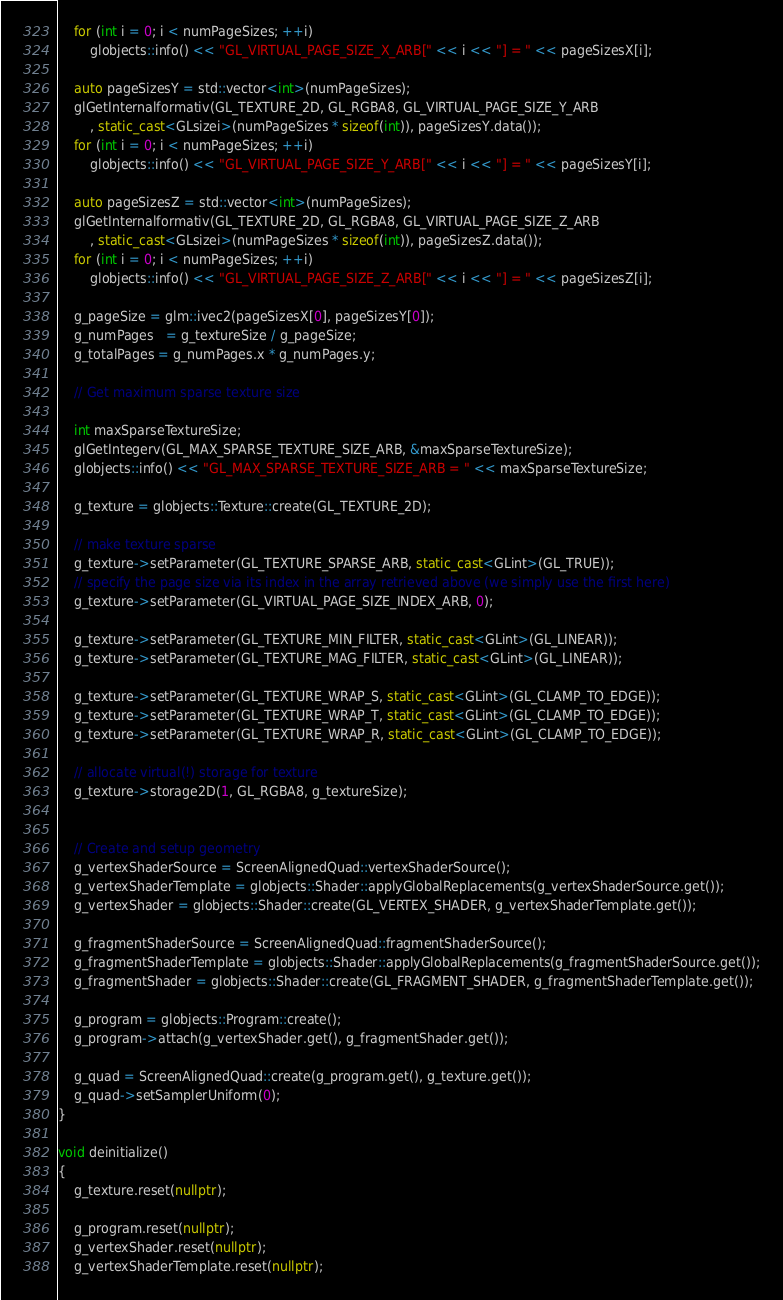Convert code to text. <code><loc_0><loc_0><loc_500><loc_500><_C++_>    for (int i = 0; i < numPageSizes; ++i)
        globjects::info() << "GL_VIRTUAL_PAGE_SIZE_X_ARB[" << i << "] = " << pageSizesX[i];

    auto pageSizesY = std::vector<int>(numPageSizes);
    glGetInternalformativ(GL_TEXTURE_2D, GL_RGBA8, GL_VIRTUAL_PAGE_SIZE_Y_ARB
        , static_cast<GLsizei>(numPageSizes * sizeof(int)), pageSizesY.data());
    for (int i = 0; i < numPageSizes; ++i)
        globjects::info() << "GL_VIRTUAL_PAGE_SIZE_Y_ARB[" << i << "] = " << pageSizesY[i];

    auto pageSizesZ = std::vector<int>(numPageSizes);
    glGetInternalformativ(GL_TEXTURE_2D, GL_RGBA8, GL_VIRTUAL_PAGE_SIZE_Z_ARB
        , static_cast<GLsizei>(numPageSizes * sizeof(int)), pageSizesZ.data());
    for (int i = 0; i < numPageSizes; ++i)
        globjects::info() << "GL_VIRTUAL_PAGE_SIZE_Z_ARB[" << i << "] = " << pageSizesZ[i];

    g_pageSize = glm::ivec2(pageSizesX[0], pageSizesY[0]);
    g_numPages   = g_textureSize / g_pageSize;
    g_totalPages = g_numPages.x * g_numPages.y;

    // Get maximum sparse texture size

    int maxSparseTextureSize;
    glGetIntegerv(GL_MAX_SPARSE_TEXTURE_SIZE_ARB, &maxSparseTextureSize);
    globjects::info() << "GL_MAX_SPARSE_TEXTURE_SIZE_ARB = " << maxSparseTextureSize;

    g_texture = globjects::Texture::create(GL_TEXTURE_2D);

    // make texture sparse
    g_texture->setParameter(GL_TEXTURE_SPARSE_ARB, static_cast<GLint>(GL_TRUE));
    // specify the page size via its index in the array retrieved above (we simply use the first here)
    g_texture->setParameter(GL_VIRTUAL_PAGE_SIZE_INDEX_ARB, 0);

    g_texture->setParameter(GL_TEXTURE_MIN_FILTER, static_cast<GLint>(GL_LINEAR));
    g_texture->setParameter(GL_TEXTURE_MAG_FILTER, static_cast<GLint>(GL_LINEAR));

    g_texture->setParameter(GL_TEXTURE_WRAP_S, static_cast<GLint>(GL_CLAMP_TO_EDGE));
    g_texture->setParameter(GL_TEXTURE_WRAP_T, static_cast<GLint>(GL_CLAMP_TO_EDGE));
    g_texture->setParameter(GL_TEXTURE_WRAP_R, static_cast<GLint>(GL_CLAMP_TO_EDGE));

    // allocate virtual(!) storage for texture
    g_texture->storage2D(1, GL_RGBA8, g_textureSize);


    // Create and setup geometry
    g_vertexShaderSource = ScreenAlignedQuad::vertexShaderSource();
    g_vertexShaderTemplate = globjects::Shader::applyGlobalReplacements(g_vertexShaderSource.get());
    g_vertexShader = globjects::Shader::create(GL_VERTEX_SHADER, g_vertexShaderTemplate.get());

    g_fragmentShaderSource = ScreenAlignedQuad::fragmentShaderSource();
    g_fragmentShaderTemplate = globjects::Shader::applyGlobalReplacements(g_fragmentShaderSource.get());
    g_fragmentShader = globjects::Shader::create(GL_FRAGMENT_SHADER, g_fragmentShaderTemplate.get());

    g_program = globjects::Program::create();
    g_program->attach(g_vertexShader.get(), g_fragmentShader.get());

    g_quad = ScreenAlignedQuad::create(g_program.get(), g_texture.get());
    g_quad->setSamplerUniform(0);
}

void deinitialize()
{
    g_texture.reset(nullptr);

    g_program.reset(nullptr);
    g_vertexShader.reset(nullptr);
    g_vertexShaderTemplate.reset(nullptr);</code> 